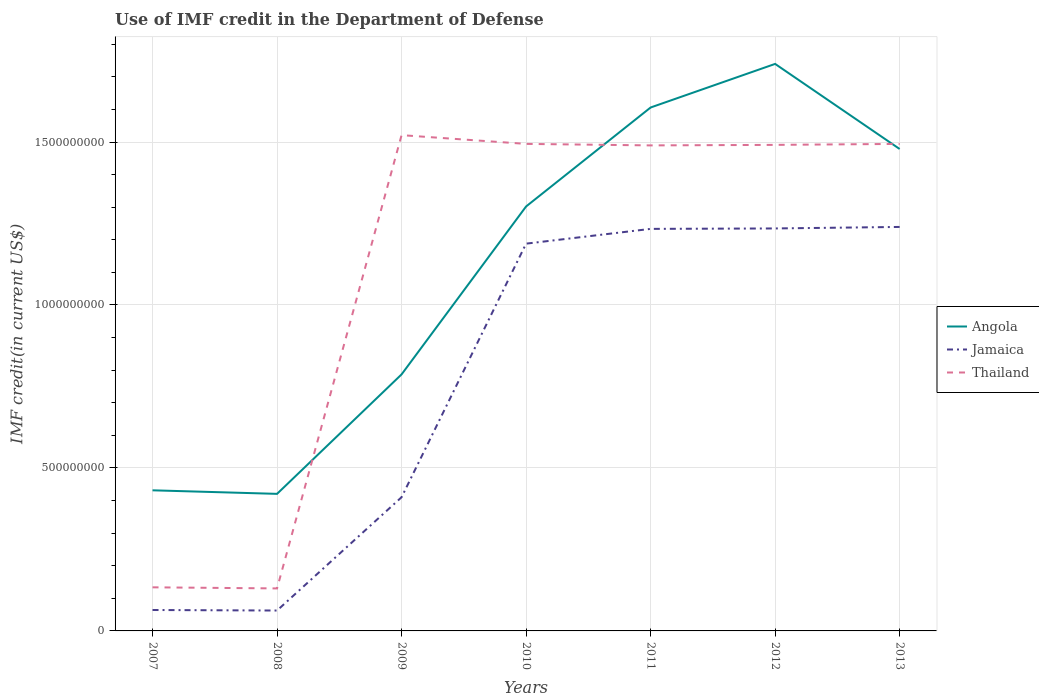How many different coloured lines are there?
Ensure brevity in your answer.  3. Does the line corresponding to Angola intersect with the line corresponding to Thailand?
Your response must be concise. Yes. Is the number of lines equal to the number of legend labels?
Give a very brief answer. Yes. Across all years, what is the maximum IMF credit in the Department of Defense in Angola?
Offer a terse response. 4.21e+08. In which year was the IMF credit in the Department of Defense in Thailand maximum?
Offer a very short reply. 2008. What is the total IMF credit in the Department of Defense in Jamaica in the graph?
Provide a succinct answer. -7.78e+08. What is the difference between the highest and the second highest IMF credit in the Department of Defense in Angola?
Provide a succinct answer. 1.32e+09. What is the difference between two consecutive major ticks on the Y-axis?
Offer a very short reply. 5.00e+08. Does the graph contain any zero values?
Provide a short and direct response. No. Does the graph contain grids?
Your answer should be very brief. Yes. Where does the legend appear in the graph?
Offer a terse response. Center right. How many legend labels are there?
Provide a short and direct response. 3. How are the legend labels stacked?
Your answer should be very brief. Vertical. What is the title of the graph?
Your response must be concise. Use of IMF credit in the Department of Defense. Does "Cayman Islands" appear as one of the legend labels in the graph?
Offer a terse response. No. What is the label or title of the Y-axis?
Offer a very short reply. IMF credit(in current US$). What is the IMF credit(in current US$) in Angola in 2007?
Keep it short and to the point. 4.31e+08. What is the IMF credit(in current US$) in Jamaica in 2007?
Ensure brevity in your answer.  6.42e+07. What is the IMF credit(in current US$) in Thailand in 2007?
Your answer should be very brief. 1.34e+08. What is the IMF credit(in current US$) in Angola in 2008?
Ensure brevity in your answer.  4.21e+08. What is the IMF credit(in current US$) in Jamaica in 2008?
Your response must be concise. 6.26e+07. What is the IMF credit(in current US$) in Thailand in 2008?
Make the answer very short. 1.30e+08. What is the IMF credit(in current US$) in Angola in 2009?
Keep it short and to the point. 7.87e+08. What is the IMF credit(in current US$) of Jamaica in 2009?
Provide a succinct answer. 4.10e+08. What is the IMF credit(in current US$) in Thailand in 2009?
Offer a very short reply. 1.52e+09. What is the IMF credit(in current US$) of Angola in 2010?
Your answer should be compact. 1.30e+09. What is the IMF credit(in current US$) in Jamaica in 2010?
Your answer should be compact. 1.19e+09. What is the IMF credit(in current US$) of Thailand in 2010?
Your answer should be compact. 1.49e+09. What is the IMF credit(in current US$) of Angola in 2011?
Offer a terse response. 1.61e+09. What is the IMF credit(in current US$) of Jamaica in 2011?
Provide a succinct answer. 1.23e+09. What is the IMF credit(in current US$) in Thailand in 2011?
Give a very brief answer. 1.49e+09. What is the IMF credit(in current US$) of Angola in 2012?
Your response must be concise. 1.74e+09. What is the IMF credit(in current US$) of Jamaica in 2012?
Provide a short and direct response. 1.23e+09. What is the IMF credit(in current US$) of Thailand in 2012?
Your response must be concise. 1.49e+09. What is the IMF credit(in current US$) of Angola in 2013?
Provide a short and direct response. 1.48e+09. What is the IMF credit(in current US$) in Jamaica in 2013?
Ensure brevity in your answer.  1.24e+09. What is the IMF credit(in current US$) in Thailand in 2013?
Ensure brevity in your answer.  1.49e+09. Across all years, what is the maximum IMF credit(in current US$) in Angola?
Your answer should be very brief. 1.74e+09. Across all years, what is the maximum IMF credit(in current US$) in Jamaica?
Provide a succinct answer. 1.24e+09. Across all years, what is the maximum IMF credit(in current US$) in Thailand?
Provide a succinct answer. 1.52e+09. Across all years, what is the minimum IMF credit(in current US$) of Angola?
Ensure brevity in your answer.  4.21e+08. Across all years, what is the minimum IMF credit(in current US$) in Jamaica?
Your answer should be very brief. 6.26e+07. Across all years, what is the minimum IMF credit(in current US$) in Thailand?
Offer a terse response. 1.30e+08. What is the total IMF credit(in current US$) in Angola in the graph?
Provide a succinct answer. 7.77e+09. What is the total IMF credit(in current US$) of Jamaica in the graph?
Provide a short and direct response. 5.43e+09. What is the total IMF credit(in current US$) in Thailand in the graph?
Give a very brief answer. 7.75e+09. What is the difference between the IMF credit(in current US$) in Angola in 2007 and that in 2008?
Your answer should be compact. 1.09e+07. What is the difference between the IMF credit(in current US$) in Jamaica in 2007 and that in 2008?
Provide a short and direct response. 1.62e+06. What is the difference between the IMF credit(in current US$) of Thailand in 2007 and that in 2008?
Offer a very short reply. 3.38e+06. What is the difference between the IMF credit(in current US$) of Angola in 2007 and that in 2009?
Provide a succinct answer. -3.56e+08. What is the difference between the IMF credit(in current US$) of Jamaica in 2007 and that in 2009?
Provide a short and direct response. -3.46e+08. What is the difference between the IMF credit(in current US$) in Thailand in 2007 and that in 2009?
Provide a succinct answer. -1.39e+09. What is the difference between the IMF credit(in current US$) of Angola in 2007 and that in 2010?
Your response must be concise. -8.71e+08. What is the difference between the IMF credit(in current US$) of Jamaica in 2007 and that in 2010?
Make the answer very short. -1.12e+09. What is the difference between the IMF credit(in current US$) in Thailand in 2007 and that in 2010?
Ensure brevity in your answer.  -1.36e+09. What is the difference between the IMF credit(in current US$) of Angola in 2007 and that in 2011?
Make the answer very short. -1.17e+09. What is the difference between the IMF credit(in current US$) in Jamaica in 2007 and that in 2011?
Your answer should be compact. -1.17e+09. What is the difference between the IMF credit(in current US$) of Thailand in 2007 and that in 2011?
Offer a very short reply. -1.36e+09. What is the difference between the IMF credit(in current US$) of Angola in 2007 and that in 2012?
Give a very brief answer. -1.31e+09. What is the difference between the IMF credit(in current US$) in Jamaica in 2007 and that in 2012?
Your answer should be compact. -1.17e+09. What is the difference between the IMF credit(in current US$) in Thailand in 2007 and that in 2012?
Offer a very short reply. -1.36e+09. What is the difference between the IMF credit(in current US$) of Angola in 2007 and that in 2013?
Provide a succinct answer. -1.05e+09. What is the difference between the IMF credit(in current US$) in Jamaica in 2007 and that in 2013?
Ensure brevity in your answer.  -1.18e+09. What is the difference between the IMF credit(in current US$) in Thailand in 2007 and that in 2013?
Offer a very short reply. -1.36e+09. What is the difference between the IMF credit(in current US$) in Angola in 2008 and that in 2009?
Keep it short and to the point. -3.67e+08. What is the difference between the IMF credit(in current US$) in Jamaica in 2008 and that in 2009?
Ensure brevity in your answer.  -3.48e+08. What is the difference between the IMF credit(in current US$) in Thailand in 2008 and that in 2009?
Ensure brevity in your answer.  -1.39e+09. What is the difference between the IMF credit(in current US$) in Angola in 2008 and that in 2010?
Your answer should be very brief. -8.82e+08. What is the difference between the IMF credit(in current US$) of Jamaica in 2008 and that in 2010?
Keep it short and to the point. -1.13e+09. What is the difference between the IMF credit(in current US$) of Thailand in 2008 and that in 2010?
Offer a very short reply. -1.36e+09. What is the difference between the IMF credit(in current US$) in Angola in 2008 and that in 2011?
Your response must be concise. -1.19e+09. What is the difference between the IMF credit(in current US$) of Jamaica in 2008 and that in 2011?
Provide a short and direct response. -1.17e+09. What is the difference between the IMF credit(in current US$) in Thailand in 2008 and that in 2011?
Ensure brevity in your answer.  -1.36e+09. What is the difference between the IMF credit(in current US$) of Angola in 2008 and that in 2012?
Offer a very short reply. -1.32e+09. What is the difference between the IMF credit(in current US$) in Jamaica in 2008 and that in 2012?
Your response must be concise. -1.17e+09. What is the difference between the IMF credit(in current US$) of Thailand in 2008 and that in 2012?
Your response must be concise. -1.36e+09. What is the difference between the IMF credit(in current US$) in Angola in 2008 and that in 2013?
Make the answer very short. -1.06e+09. What is the difference between the IMF credit(in current US$) in Jamaica in 2008 and that in 2013?
Make the answer very short. -1.18e+09. What is the difference between the IMF credit(in current US$) in Thailand in 2008 and that in 2013?
Keep it short and to the point. -1.36e+09. What is the difference between the IMF credit(in current US$) of Angola in 2009 and that in 2010?
Your response must be concise. -5.15e+08. What is the difference between the IMF credit(in current US$) of Jamaica in 2009 and that in 2010?
Your response must be concise. -7.78e+08. What is the difference between the IMF credit(in current US$) in Thailand in 2009 and that in 2010?
Provide a succinct answer. 2.68e+07. What is the difference between the IMF credit(in current US$) of Angola in 2009 and that in 2011?
Offer a terse response. -8.19e+08. What is the difference between the IMF credit(in current US$) of Jamaica in 2009 and that in 2011?
Ensure brevity in your answer.  -8.23e+08. What is the difference between the IMF credit(in current US$) of Thailand in 2009 and that in 2011?
Keep it short and to the point. 3.15e+07. What is the difference between the IMF credit(in current US$) of Angola in 2009 and that in 2012?
Your response must be concise. -9.53e+08. What is the difference between the IMF credit(in current US$) of Jamaica in 2009 and that in 2012?
Give a very brief answer. -8.25e+08. What is the difference between the IMF credit(in current US$) in Thailand in 2009 and that in 2012?
Your answer should be compact. 2.99e+07. What is the difference between the IMF credit(in current US$) of Angola in 2009 and that in 2013?
Provide a short and direct response. -6.92e+08. What is the difference between the IMF credit(in current US$) in Jamaica in 2009 and that in 2013?
Your answer should be very brief. -8.29e+08. What is the difference between the IMF credit(in current US$) in Thailand in 2009 and that in 2013?
Offer a very short reply. 2.69e+07. What is the difference between the IMF credit(in current US$) of Angola in 2010 and that in 2011?
Offer a very short reply. -3.04e+08. What is the difference between the IMF credit(in current US$) in Jamaica in 2010 and that in 2011?
Your answer should be very brief. -4.53e+07. What is the difference between the IMF credit(in current US$) of Thailand in 2010 and that in 2011?
Offer a terse response. 4.62e+06. What is the difference between the IMF credit(in current US$) in Angola in 2010 and that in 2012?
Provide a short and direct response. -4.37e+08. What is the difference between the IMF credit(in current US$) in Jamaica in 2010 and that in 2012?
Ensure brevity in your answer.  -4.66e+07. What is the difference between the IMF credit(in current US$) of Thailand in 2010 and that in 2012?
Keep it short and to the point. 3.02e+06. What is the difference between the IMF credit(in current US$) in Angola in 2010 and that in 2013?
Provide a succinct answer. -1.76e+08. What is the difference between the IMF credit(in current US$) in Jamaica in 2010 and that in 2013?
Provide a short and direct response. -5.13e+07. What is the difference between the IMF credit(in current US$) in Thailand in 2010 and that in 2013?
Ensure brevity in your answer.  2.90e+04. What is the difference between the IMF credit(in current US$) in Angola in 2011 and that in 2012?
Offer a very short reply. -1.34e+08. What is the difference between the IMF credit(in current US$) of Jamaica in 2011 and that in 2012?
Provide a short and direct response. -1.32e+06. What is the difference between the IMF credit(in current US$) in Thailand in 2011 and that in 2012?
Your answer should be compact. -1.60e+06. What is the difference between the IMF credit(in current US$) in Angola in 2011 and that in 2013?
Offer a terse response. 1.27e+08. What is the difference between the IMF credit(in current US$) of Jamaica in 2011 and that in 2013?
Provide a short and direct response. -5.98e+06. What is the difference between the IMF credit(in current US$) in Thailand in 2011 and that in 2013?
Offer a terse response. -4.59e+06. What is the difference between the IMF credit(in current US$) of Angola in 2012 and that in 2013?
Provide a short and direct response. 2.61e+08. What is the difference between the IMF credit(in current US$) in Jamaica in 2012 and that in 2013?
Your answer should be compact. -4.65e+06. What is the difference between the IMF credit(in current US$) of Thailand in 2012 and that in 2013?
Your answer should be compact. -2.99e+06. What is the difference between the IMF credit(in current US$) of Angola in 2007 and the IMF credit(in current US$) of Jamaica in 2008?
Provide a succinct answer. 3.69e+08. What is the difference between the IMF credit(in current US$) in Angola in 2007 and the IMF credit(in current US$) in Thailand in 2008?
Your answer should be compact. 3.01e+08. What is the difference between the IMF credit(in current US$) of Jamaica in 2007 and the IMF credit(in current US$) of Thailand in 2008?
Offer a very short reply. -6.62e+07. What is the difference between the IMF credit(in current US$) in Angola in 2007 and the IMF credit(in current US$) in Jamaica in 2009?
Provide a short and direct response. 2.12e+07. What is the difference between the IMF credit(in current US$) of Angola in 2007 and the IMF credit(in current US$) of Thailand in 2009?
Give a very brief answer. -1.09e+09. What is the difference between the IMF credit(in current US$) in Jamaica in 2007 and the IMF credit(in current US$) in Thailand in 2009?
Make the answer very short. -1.46e+09. What is the difference between the IMF credit(in current US$) of Angola in 2007 and the IMF credit(in current US$) of Jamaica in 2010?
Make the answer very short. -7.57e+08. What is the difference between the IMF credit(in current US$) in Angola in 2007 and the IMF credit(in current US$) in Thailand in 2010?
Keep it short and to the point. -1.06e+09. What is the difference between the IMF credit(in current US$) of Jamaica in 2007 and the IMF credit(in current US$) of Thailand in 2010?
Provide a short and direct response. -1.43e+09. What is the difference between the IMF credit(in current US$) in Angola in 2007 and the IMF credit(in current US$) in Jamaica in 2011?
Make the answer very short. -8.02e+08. What is the difference between the IMF credit(in current US$) of Angola in 2007 and the IMF credit(in current US$) of Thailand in 2011?
Provide a succinct answer. -1.06e+09. What is the difference between the IMF credit(in current US$) in Jamaica in 2007 and the IMF credit(in current US$) in Thailand in 2011?
Offer a terse response. -1.43e+09. What is the difference between the IMF credit(in current US$) in Angola in 2007 and the IMF credit(in current US$) in Jamaica in 2012?
Offer a terse response. -8.03e+08. What is the difference between the IMF credit(in current US$) of Angola in 2007 and the IMF credit(in current US$) of Thailand in 2012?
Provide a succinct answer. -1.06e+09. What is the difference between the IMF credit(in current US$) in Jamaica in 2007 and the IMF credit(in current US$) in Thailand in 2012?
Keep it short and to the point. -1.43e+09. What is the difference between the IMF credit(in current US$) of Angola in 2007 and the IMF credit(in current US$) of Jamaica in 2013?
Your response must be concise. -8.08e+08. What is the difference between the IMF credit(in current US$) of Angola in 2007 and the IMF credit(in current US$) of Thailand in 2013?
Provide a succinct answer. -1.06e+09. What is the difference between the IMF credit(in current US$) of Jamaica in 2007 and the IMF credit(in current US$) of Thailand in 2013?
Ensure brevity in your answer.  -1.43e+09. What is the difference between the IMF credit(in current US$) of Angola in 2008 and the IMF credit(in current US$) of Jamaica in 2009?
Offer a very short reply. 1.03e+07. What is the difference between the IMF credit(in current US$) of Angola in 2008 and the IMF credit(in current US$) of Thailand in 2009?
Your answer should be very brief. -1.10e+09. What is the difference between the IMF credit(in current US$) in Jamaica in 2008 and the IMF credit(in current US$) in Thailand in 2009?
Provide a succinct answer. -1.46e+09. What is the difference between the IMF credit(in current US$) in Angola in 2008 and the IMF credit(in current US$) in Jamaica in 2010?
Your answer should be compact. -7.68e+08. What is the difference between the IMF credit(in current US$) of Angola in 2008 and the IMF credit(in current US$) of Thailand in 2010?
Provide a succinct answer. -1.07e+09. What is the difference between the IMF credit(in current US$) in Jamaica in 2008 and the IMF credit(in current US$) in Thailand in 2010?
Make the answer very short. -1.43e+09. What is the difference between the IMF credit(in current US$) in Angola in 2008 and the IMF credit(in current US$) in Jamaica in 2011?
Make the answer very short. -8.13e+08. What is the difference between the IMF credit(in current US$) in Angola in 2008 and the IMF credit(in current US$) in Thailand in 2011?
Your answer should be compact. -1.07e+09. What is the difference between the IMF credit(in current US$) of Jamaica in 2008 and the IMF credit(in current US$) of Thailand in 2011?
Keep it short and to the point. -1.43e+09. What is the difference between the IMF credit(in current US$) of Angola in 2008 and the IMF credit(in current US$) of Jamaica in 2012?
Ensure brevity in your answer.  -8.14e+08. What is the difference between the IMF credit(in current US$) of Angola in 2008 and the IMF credit(in current US$) of Thailand in 2012?
Make the answer very short. -1.07e+09. What is the difference between the IMF credit(in current US$) of Jamaica in 2008 and the IMF credit(in current US$) of Thailand in 2012?
Keep it short and to the point. -1.43e+09. What is the difference between the IMF credit(in current US$) in Angola in 2008 and the IMF credit(in current US$) in Jamaica in 2013?
Make the answer very short. -8.19e+08. What is the difference between the IMF credit(in current US$) in Angola in 2008 and the IMF credit(in current US$) in Thailand in 2013?
Your answer should be very brief. -1.07e+09. What is the difference between the IMF credit(in current US$) in Jamaica in 2008 and the IMF credit(in current US$) in Thailand in 2013?
Ensure brevity in your answer.  -1.43e+09. What is the difference between the IMF credit(in current US$) in Angola in 2009 and the IMF credit(in current US$) in Jamaica in 2010?
Your answer should be very brief. -4.01e+08. What is the difference between the IMF credit(in current US$) in Angola in 2009 and the IMF credit(in current US$) in Thailand in 2010?
Provide a succinct answer. -7.07e+08. What is the difference between the IMF credit(in current US$) of Jamaica in 2009 and the IMF credit(in current US$) of Thailand in 2010?
Keep it short and to the point. -1.08e+09. What is the difference between the IMF credit(in current US$) of Angola in 2009 and the IMF credit(in current US$) of Jamaica in 2011?
Your response must be concise. -4.46e+08. What is the difference between the IMF credit(in current US$) in Angola in 2009 and the IMF credit(in current US$) in Thailand in 2011?
Provide a succinct answer. -7.03e+08. What is the difference between the IMF credit(in current US$) of Jamaica in 2009 and the IMF credit(in current US$) of Thailand in 2011?
Your answer should be compact. -1.08e+09. What is the difference between the IMF credit(in current US$) of Angola in 2009 and the IMF credit(in current US$) of Jamaica in 2012?
Provide a succinct answer. -4.48e+08. What is the difference between the IMF credit(in current US$) in Angola in 2009 and the IMF credit(in current US$) in Thailand in 2012?
Offer a terse response. -7.04e+08. What is the difference between the IMF credit(in current US$) of Jamaica in 2009 and the IMF credit(in current US$) of Thailand in 2012?
Give a very brief answer. -1.08e+09. What is the difference between the IMF credit(in current US$) in Angola in 2009 and the IMF credit(in current US$) in Jamaica in 2013?
Keep it short and to the point. -4.52e+08. What is the difference between the IMF credit(in current US$) in Angola in 2009 and the IMF credit(in current US$) in Thailand in 2013?
Offer a very short reply. -7.07e+08. What is the difference between the IMF credit(in current US$) of Jamaica in 2009 and the IMF credit(in current US$) of Thailand in 2013?
Your response must be concise. -1.08e+09. What is the difference between the IMF credit(in current US$) in Angola in 2010 and the IMF credit(in current US$) in Jamaica in 2011?
Provide a short and direct response. 6.88e+07. What is the difference between the IMF credit(in current US$) in Angola in 2010 and the IMF credit(in current US$) in Thailand in 2011?
Provide a succinct answer. -1.87e+08. What is the difference between the IMF credit(in current US$) of Jamaica in 2010 and the IMF credit(in current US$) of Thailand in 2011?
Offer a terse response. -3.01e+08. What is the difference between the IMF credit(in current US$) of Angola in 2010 and the IMF credit(in current US$) of Jamaica in 2012?
Keep it short and to the point. 6.74e+07. What is the difference between the IMF credit(in current US$) of Angola in 2010 and the IMF credit(in current US$) of Thailand in 2012?
Provide a short and direct response. -1.89e+08. What is the difference between the IMF credit(in current US$) in Jamaica in 2010 and the IMF credit(in current US$) in Thailand in 2012?
Provide a succinct answer. -3.03e+08. What is the difference between the IMF credit(in current US$) of Angola in 2010 and the IMF credit(in current US$) of Jamaica in 2013?
Provide a short and direct response. 6.28e+07. What is the difference between the IMF credit(in current US$) in Angola in 2010 and the IMF credit(in current US$) in Thailand in 2013?
Provide a succinct answer. -1.92e+08. What is the difference between the IMF credit(in current US$) in Jamaica in 2010 and the IMF credit(in current US$) in Thailand in 2013?
Your answer should be compact. -3.06e+08. What is the difference between the IMF credit(in current US$) of Angola in 2011 and the IMF credit(in current US$) of Jamaica in 2012?
Give a very brief answer. 3.71e+08. What is the difference between the IMF credit(in current US$) in Angola in 2011 and the IMF credit(in current US$) in Thailand in 2012?
Provide a short and direct response. 1.15e+08. What is the difference between the IMF credit(in current US$) of Jamaica in 2011 and the IMF credit(in current US$) of Thailand in 2012?
Offer a very short reply. -2.58e+08. What is the difference between the IMF credit(in current US$) of Angola in 2011 and the IMF credit(in current US$) of Jamaica in 2013?
Give a very brief answer. 3.66e+08. What is the difference between the IMF credit(in current US$) of Angola in 2011 and the IMF credit(in current US$) of Thailand in 2013?
Ensure brevity in your answer.  1.12e+08. What is the difference between the IMF credit(in current US$) of Jamaica in 2011 and the IMF credit(in current US$) of Thailand in 2013?
Your answer should be very brief. -2.61e+08. What is the difference between the IMF credit(in current US$) of Angola in 2012 and the IMF credit(in current US$) of Jamaica in 2013?
Ensure brevity in your answer.  5.00e+08. What is the difference between the IMF credit(in current US$) in Angola in 2012 and the IMF credit(in current US$) in Thailand in 2013?
Your response must be concise. 2.45e+08. What is the difference between the IMF credit(in current US$) of Jamaica in 2012 and the IMF credit(in current US$) of Thailand in 2013?
Provide a short and direct response. -2.59e+08. What is the average IMF credit(in current US$) in Angola per year?
Ensure brevity in your answer.  1.11e+09. What is the average IMF credit(in current US$) of Jamaica per year?
Provide a succinct answer. 7.76e+08. What is the average IMF credit(in current US$) of Thailand per year?
Offer a very short reply. 1.11e+09. In the year 2007, what is the difference between the IMF credit(in current US$) in Angola and IMF credit(in current US$) in Jamaica?
Keep it short and to the point. 3.67e+08. In the year 2007, what is the difference between the IMF credit(in current US$) of Angola and IMF credit(in current US$) of Thailand?
Give a very brief answer. 2.98e+08. In the year 2007, what is the difference between the IMF credit(in current US$) of Jamaica and IMF credit(in current US$) of Thailand?
Your answer should be very brief. -6.96e+07. In the year 2008, what is the difference between the IMF credit(in current US$) of Angola and IMF credit(in current US$) of Jamaica?
Offer a terse response. 3.58e+08. In the year 2008, what is the difference between the IMF credit(in current US$) of Angola and IMF credit(in current US$) of Thailand?
Make the answer very short. 2.90e+08. In the year 2008, what is the difference between the IMF credit(in current US$) of Jamaica and IMF credit(in current US$) of Thailand?
Offer a terse response. -6.78e+07. In the year 2009, what is the difference between the IMF credit(in current US$) in Angola and IMF credit(in current US$) in Jamaica?
Offer a terse response. 3.77e+08. In the year 2009, what is the difference between the IMF credit(in current US$) in Angola and IMF credit(in current US$) in Thailand?
Provide a short and direct response. -7.34e+08. In the year 2009, what is the difference between the IMF credit(in current US$) in Jamaica and IMF credit(in current US$) in Thailand?
Provide a succinct answer. -1.11e+09. In the year 2010, what is the difference between the IMF credit(in current US$) of Angola and IMF credit(in current US$) of Jamaica?
Offer a very short reply. 1.14e+08. In the year 2010, what is the difference between the IMF credit(in current US$) of Angola and IMF credit(in current US$) of Thailand?
Keep it short and to the point. -1.92e+08. In the year 2010, what is the difference between the IMF credit(in current US$) of Jamaica and IMF credit(in current US$) of Thailand?
Ensure brevity in your answer.  -3.06e+08. In the year 2011, what is the difference between the IMF credit(in current US$) of Angola and IMF credit(in current US$) of Jamaica?
Ensure brevity in your answer.  3.72e+08. In the year 2011, what is the difference between the IMF credit(in current US$) of Angola and IMF credit(in current US$) of Thailand?
Keep it short and to the point. 1.16e+08. In the year 2011, what is the difference between the IMF credit(in current US$) in Jamaica and IMF credit(in current US$) in Thailand?
Offer a very short reply. -2.56e+08. In the year 2012, what is the difference between the IMF credit(in current US$) of Angola and IMF credit(in current US$) of Jamaica?
Keep it short and to the point. 5.05e+08. In the year 2012, what is the difference between the IMF credit(in current US$) of Angola and IMF credit(in current US$) of Thailand?
Keep it short and to the point. 2.48e+08. In the year 2012, what is the difference between the IMF credit(in current US$) of Jamaica and IMF credit(in current US$) of Thailand?
Provide a short and direct response. -2.56e+08. In the year 2013, what is the difference between the IMF credit(in current US$) of Angola and IMF credit(in current US$) of Jamaica?
Ensure brevity in your answer.  2.39e+08. In the year 2013, what is the difference between the IMF credit(in current US$) in Angola and IMF credit(in current US$) in Thailand?
Provide a short and direct response. -1.56e+07. In the year 2013, what is the difference between the IMF credit(in current US$) in Jamaica and IMF credit(in current US$) in Thailand?
Keep it short and to the point. -2.55e+08. What is the ratio of the IMF credit(in current US$) of Angola in 2007 to that in 2009?
Make the answer very short. 0.55. What is the ratio of the IMF credit(in current US$) in Jamaica in 2007 to that in 2009?
Offer a terse response. 0.16. What is the ratio of the IMF credit(in current US$) of Thailand in 2007 to that in 2009?
Give a very brief answer. 0.09. What is the ratio of the IMF credit(in current US$) in Angola in 2007 to that in 2010?
Your response must be concise. 0.33. What is the ratio of the IMF credit(in current US$) of Jamaica in 2007 to that in 2010?
Your answer should be compact. 0.05. What is the ratio of the IMF credit(in current US$) of Thailand in 2007 to that in 2010?
Your answer should be compact. 0.09. What is the ratio of the IMF credit(in current US$) in Angola in 2007 to that in 2011?
Offer a terse response. 0.27. What is the ratio of the IMF credit(in current US$) of Jamaica in 2007 to that in 2011?
Provide a short and direct response. 0.05. What is the ratio of the IMF credit(in current US$) in Thailand in 2007 to that in 2011?
Keep it short and to the point. 0.09. What is the ratio of the IMF credit(in current US$) in Angola in 2007 to that in 2012?
Provide a succinct answer. 0.25. What is the ratio of the IMF credit(in current US$) of Jamaica in 2007 to that in 2012?
Ensure brevity in your answer.  0.05. What is the ratio of the IMF credit(in current US$) of Thailand in 2007 to that in 2012?
Offer a very short reply. 0.09. What is the ratio of the IMF credit(in current US$) of Angola in 2007 to that in 2013?
Your answer should be very brief. 0.29. What is the ratio of the IMF credit(in current US$) of Jamaica in 2007 to that in 2013?
Your response must be concise. 0.05. What is the ratio of the IMF credit(in current US$) of Thailand in 2007 to that in 2013?
Provide a succinct answer. 0.09. What is the ratio of the IMF credit(in current US$) of Angola in 2008 to that in 2009?
Make the answer very short. 0.53. What is the ratio of the IMF credit(in current US$) of Jamaica in 2008 to that in 2009?
Keep it short and to the point. 0.15. What is the ratio of the IMF credit(in current US$) of Thailand in 2008 to that in 2009?
Your answer should be compact. 0.09. What is the ratio of the IMF credit(in current US$) of Angola in 2008 to that in 2010?
Your answer should be very brief. 0.32. What is the ratio of the IMF credit(in current US$) in Jamaica in 2008 to that in 2010?
Offer a terse response. 0.05. What is the ratio of the IMF credit(in current US$) of Thailand in 2008 to that in 2010?
Ensure brevity in your answer.  0.09. What is the ratio of the IMF credit(in current US$) in Angola in 2008 to that in 2011?
Your answer should be very brief. 0.26. What is the ratio of the IMF credit(in current US$) in Jamaica in 2008 to that in 2011?
Keep it short and to the point. 0.05. What is the ratio of the IMF credit(in current US$) of Thailand in 2008 to that in 2011?
Offer a very short reply. 0.09. What is the ratio of the IMF credit(in current US$) of Angola in 2008 to that in 2012?
Offer a very short reply. 0.24. What is the ratio of the IMF credit(in current US$) of Jamaica in 2008 to that in 2012?
Give a very brief answer. 0.05. What is the ratio of the IMF credit(in current US$) of Thailand in 2008 to that in 2012?
Ensure brevity in your answer.  0.09. What is the ratio of the IMF credit(in current US$) in Angola in 2008 to that in 2013?
Provide a short and direct response. 0.28. What is the ratio of the IMF credit(in current US$) of Jamaica in 2008 to that in 2013?
Offer a terse response. 0.05. What is the ratio of the IMF credit(in current US$) of Thailand in 2008 to that in 2013?
Your answer should be very brief. 0.09. What is the ratio of the IMF credit(in current US$) in Angola in 2009 to that in 2010?
Give a very brief answer. 0.6. What is the ratio of the IMF credit(in current US$) of Jamaica in 2009 to that in 2010?
Offer a terse response. 0.35. What is the ratio of the IMF credit(in current US$) in Thailand in 2009 to that in 2010?
Provide a short and direct response. 1.02. What is the ratio of the IMF credit(in current US$) of Angola in 2009 to that in 2011?
Provide a succinct answer. 0.49. What is the ratio of the IMF credit(in current US$) of Jamaica in 2009 to that in 2011?
Give a very brief answer. 0.33. What is the ratio of the IMF credit(in current US$) of Thailand in 2009 to that in 2011?
Your response must be concise. 1.02. What is the ratio of the IMF credit(in current US$) of Angola in 2009 to that in 2012?
Give a very brief answer. 0.45. What is the ratio of the IMF credit(in current US$) in Jamaica in 2009 to that in 2012?
Keep it short and to the point. 0.33. What is the ratio of the IMF credit(in current US$) in Thailand in 2009 to that in 2012?
Provide a short and direct response. 1.02. What is the ratio of the IMF credit(in current US$) of Angola in 2009 to that in 2013?
Offer a terse response. 0.53. What is the ratio of the IMF credit(in current US$) in Jamaica in 2009 to that in 2013?
Your response must be concise. 0.33. What is the ratio of the IMF credit(in current US$) of Angola in 2010 to that in 2011?
Ensure brevity in your answer.  0.81. What is the ratio of the IMF credit(in current US$) in Jamaica in 2010 to that in 2011?
Your response must be concise. 0.96. What is the ratio of the IMF credit(in current US$) of Angola in 2010 to that in 2012?
Offer a very short reply. 0.75. What is the ratio of the IMF credit(in current US$) in Jamaica in 2010 to that in 2012?
Your response must be concise. 0.96. What is the ratio of the IMF credit(in current US$) in Angola in 2010 to that in 2013?
Your answer should be very brief. 0.88. What is the ratio of the IMF credit(in current US$) of Jamaica in 2010 to that in 2013?
Ensure brevity in your answer.  0.96. What is the ratio of the IMF credit(in current US$) in Angola in 2011 to that in 2012?
Provide a succinct answer. 0.92. What is the ratio of the IMF credit(in current US$) of Angola in 2011 to that in 2013?
Offer a terse response. 1.09. What is the ratio of the IMF credit(in current US$) in Angola in 2012 to that in 2013?
Your answer should be very brief. 1.18. What is the difference between the highest and the second highest IMF credit(in current US$) in Angola?
Your response must be concise. 1.34e+08. What is the difference between the highest and the second highest IMF credit(in current US$) in Jamaica?
Make the answer very short. 4.65e+06. What is the difference between the highest and the second highest IMF credit(in current US$) of Thailand?
Your answer should be very brief. 2.68e+07. What is the difference between the highest and the lowest IMF credit(in current US$) of Angola?
Offer a terse response. 1.32e+09. What is the difference between the highest and the lowest IMF credit(in current US$) in Jamaica?
Keep it short and to the point. 1.18e+09. What is the difference between the highest and the lowest IMF credit(in current US$) in Thailand?
Provide a succinct answer. 1.39e+09. 